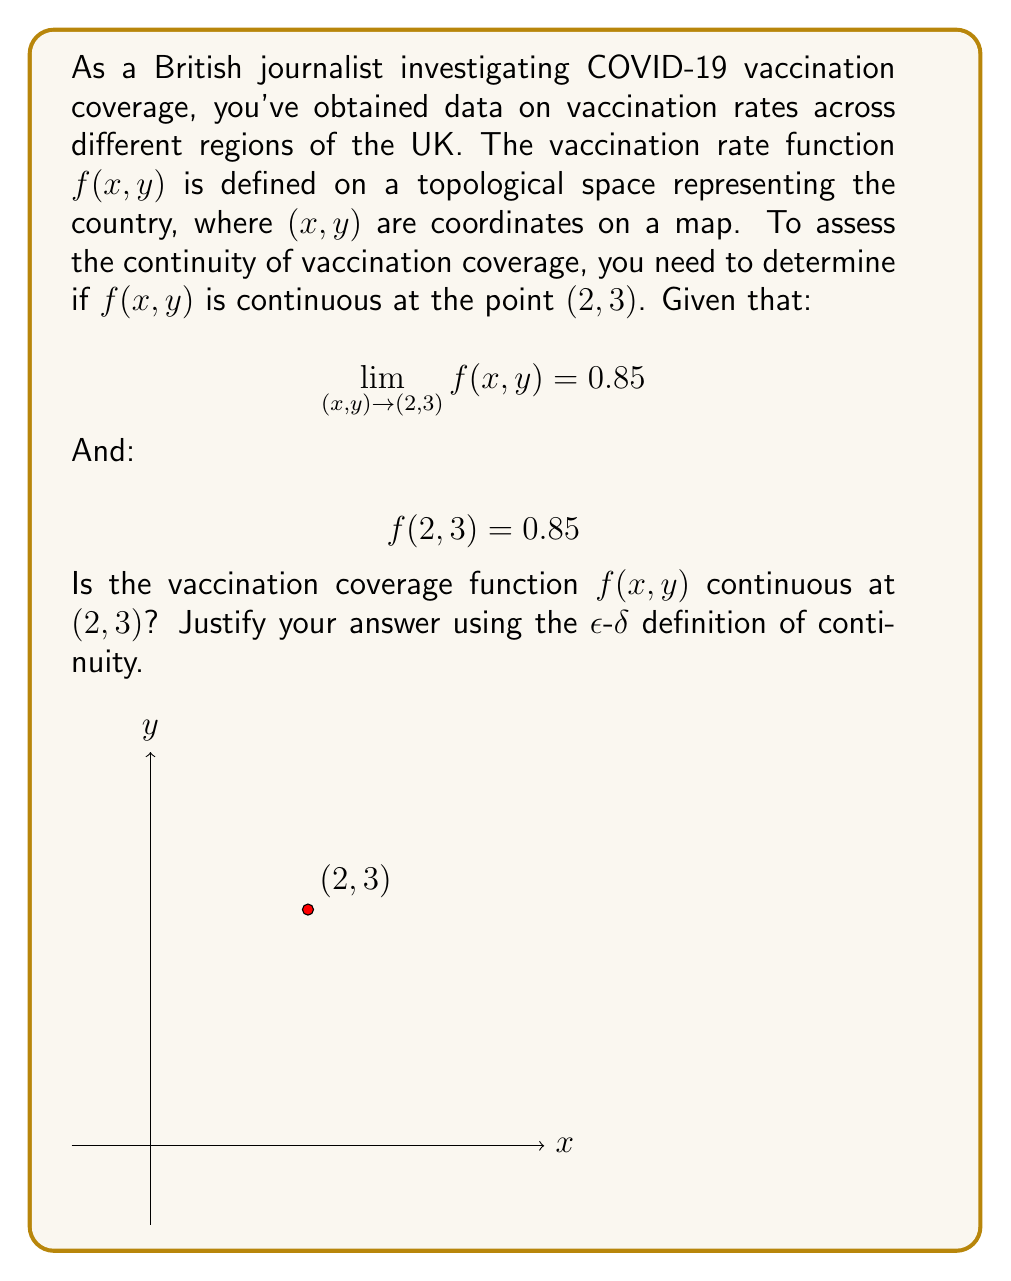Can you answer this question? To prove that $f(x, y)$ is continuous at $(2, 3)$, we need to use the $\epsilon$-$\delta$ definition of continuity for functions of two variables. The function is continuous at $(2, 3)$ if:

For every $\epsilon > 0$, there exists a $\delta > 0$ such that:

If $\sqrt{(x-2)^2 + (y-3)^2} < \delta$, then $|f(x,y) - f(2,3)| < \epsilon$

Let's check if this condition is satisfied:

1) We're given that $\lim_{(x,y) \to (2,3)} f(x,y) = 0.85$ and $f(2, 3) = 0.85$

2) This means that for any $\epsilon > 0$, we can find a $\delta > 0$ such that:

   If $\sqrt{(x-2)^2 + (y-3)^2} < \delta$, then $|f(x,y) - 0.85| < \epsilon$

3) Since $f(2, 3) = 0.85$, we can rewrite this as:

   If $\sqrt{(x-2)^2 + (y-3)^2} < \delta$, then $|f(x,y) - f(2,3)| < \epsilon$

4) This is exactly the definition of continuity at $(2, 3)$

Therefore, the vaccination coverage function $f(x, y)$ is continuous at $(2, 3)$. This implies that the vaccination rate changes smoothly around this point, without any abrupt jumps or gaps in coverage.
Answer: Yes, $f(x,y)$ is continuous at $(2,3)$. 